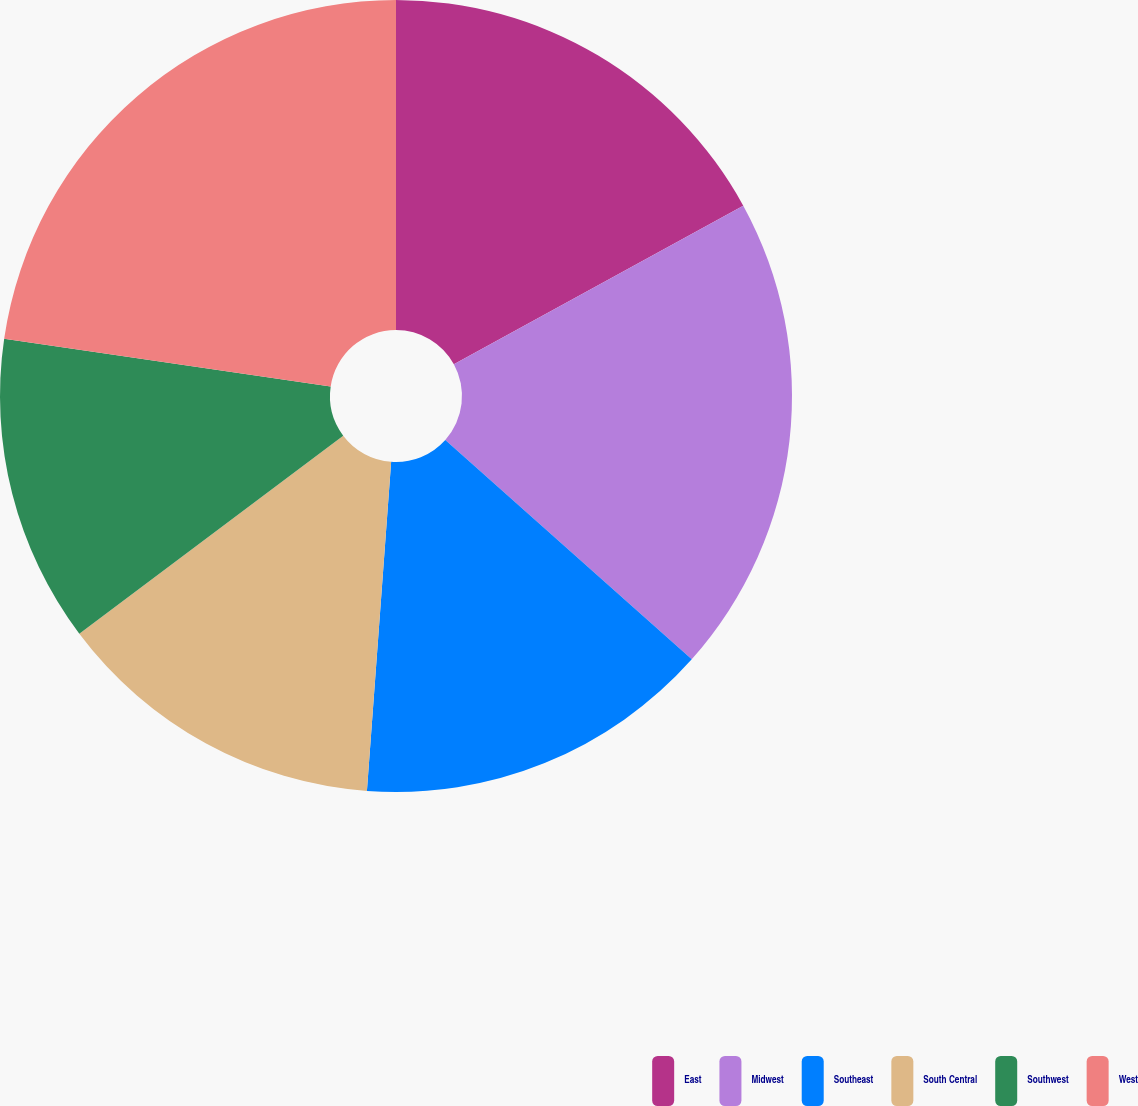Convert chart to OTSL. <chart><loc_0><loc_0><loc_500><loc_500><pie_chart><fcel>East<fcel>Midwest<fcel>Southeast<fcel>South Central<fcel>Southwest<fcel>West<nl><fcel>17.02%<fcel>19.56%<fcel>14.59%<fcel>13.58%<fcel>12.56%<fcel>22.69%<nl></chart> 